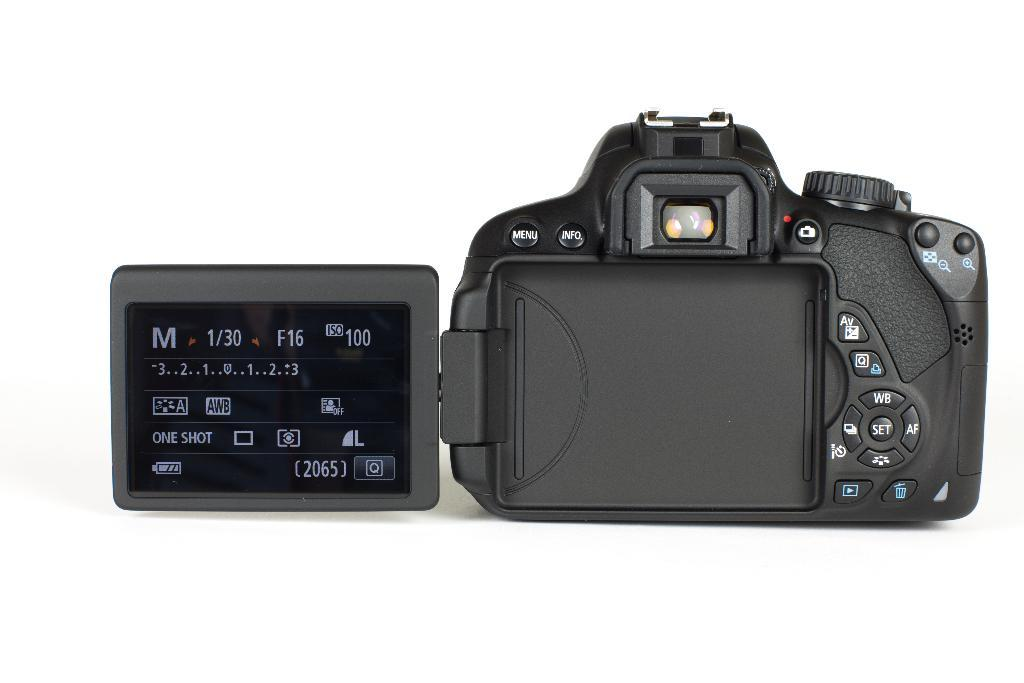What is the main subject of the image? The main subject of the image is a camera. Can you describe the surface the camera is on? The camera is on a white surface. Where is the camera located in relation to the image? The camera is in the foreground of the image. What type of fear is the camera experiencing in the image? Cameras do not experience fear, as they are inanimate objects. 